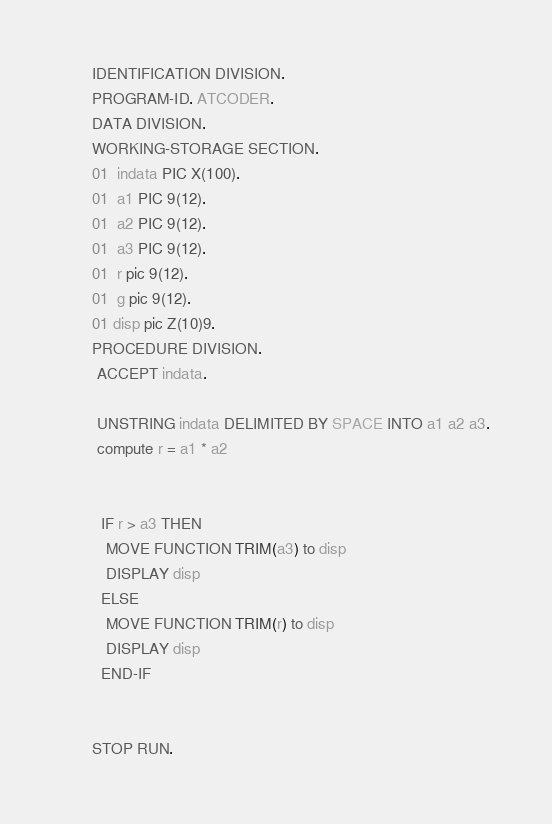<code> <loc_0><loc_0><loc_500><loc_500><_COBOL_>       IDENTIFICATION DIVISION.
       PROGRAM-ID. ATCODER.
       DATA DIVISION.
       WORKING-STORAGE SECTION.
       01  indata PIC X(100).
       01  a1 PIC 9(12).
       01  a2 PIC 9(12).
       01  a3 PIC 9(12).
       01  r pic 9(12).
       01  g pic 9(12).
       01 disp pic Z(10)9.
       PROCEDURE DIVISION.
        ACCEPT indata.
        
        UNSTRING indata DELIMITED BY SPACE INTO a1 a2 a3.
        compute r = a1 * a2


         IF r > a3 THEN
          MOVE FUNCTION TRIM(a3) to disp
          DISPLAY disp
         ELSE
          MOVE FUNCTION TRIM(r) to disp
          DISPLAY disp
         END-IF


       STOP RUN.
</code> 